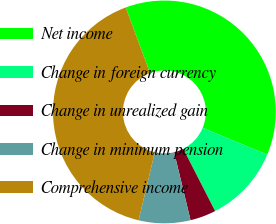<chart> <loc_0><loc_0><loc_500><loc_500><pie_chart><fcel>Net income<fcel>Change in foreign currency<fcel>Change in unrealized gain<fcel>Change in minimum pension<fcel>Comprehensive income<nl><fcel>36.9%<fcel>11.22%<fcel>3.75%<fcel>7.49%<fcel>40.64%<nl></chart> 